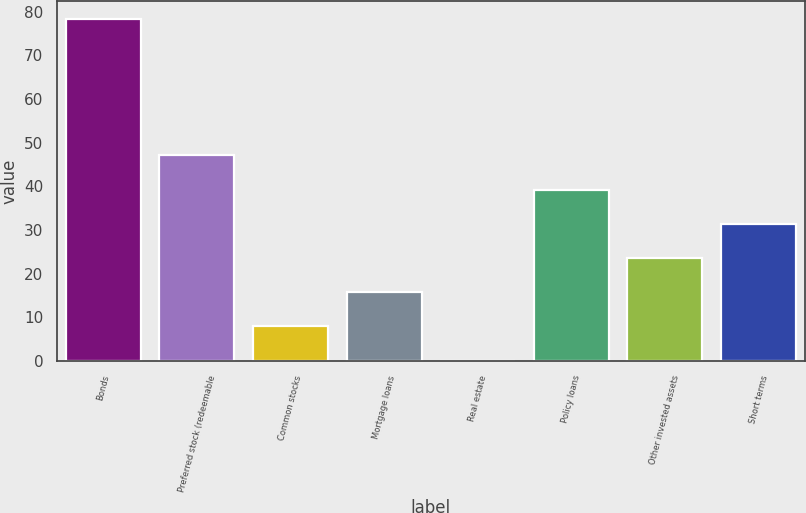Convert chart to OTSL. <chart><loc_0><loc_0><loc_500><loc_500><bar_chart><fcel>Bonds<fcel>Preferred stock (redeemable<fcel>Common stocks<fcel>Mortgage loans<fcel>Real estate<fcel>Policy loans<fcel>Other invested assets<fcel>Short terms<nl><fcel>78.4<fcel>47.08<fcel>7.93<fcel>15.76<fcel>0.1<fcel>39.25<fcel>23.59<fcel>31.42<nl></chart> 